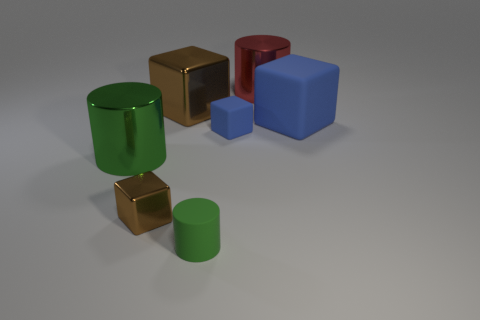What shape is the brown thing that is behind the small blue cube?
Your response must be concise. Cube. There is a tiny rubber object that is behind the large cylinder in front of the big rubber block; what number of tiny green cylinders are to the right of it?
Your response must be concise. 0. There is a big metallic cylinder to the left of the small brown thing; does it have the same color as the small rubber block?
Your answer should be very brief. No. How many other things are there of the same shape as the big green shiny thing?
Your answer should be compact. 2. How many other objects are the same material as the big green object?
Provide a short and direct response. 3. What is the green object that is behind the small green object on the right side of the brown thing in front of the large rubber thing made of?
Ensure brevity in your answer.  Metal. Are the small green thing and the big blue thing made of the same material?
Provide a succinct answer. Yes. How many balls are tiny brown objects or tiny gray objects?
Your answer should be compact. 0. The tiny thing that is on the left side of the green matte thing is what color?
Offer a very short reply. Brown. How many shiny things are red things or tiny blue objects?
Provide a short and direct response. 1. 